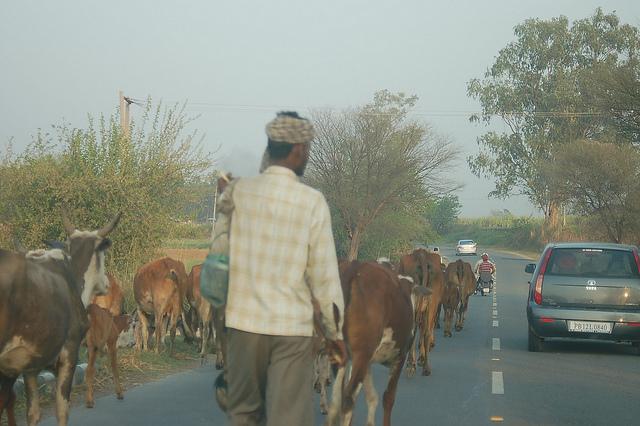What is blocking the car?
Write a very short answer. Cows. What color is the car?
Answer briefly. Gray. Which hand is raised in the air?
Answer briefly. Left. Will these cows hit the man on the bike?
Concise answer only. No. How many people are there?
Short answer required. 2. Where is the photo taken?
Keep it brief. Outside. Is this a humane way to raise cattle?
Quick response, please. Yes. What animal is sitting in front of the cow?
Short answer required. Human. Which animals are these?
Quick response, please. Cows. How many cars in the picture?
Quick response, please. 2. Are drivers of the cars applying their brakes?
Write a very short answer. No. What is the fastest mode of transportation pictured here?
Answer briefly. Car. Is this in africa?
Concise answer only. No. What color are the plants?
Short answer required. Green. What animals are on the streets?
Quick response, please. Cows. What is this women walking?
Keep it brief. Cows. 